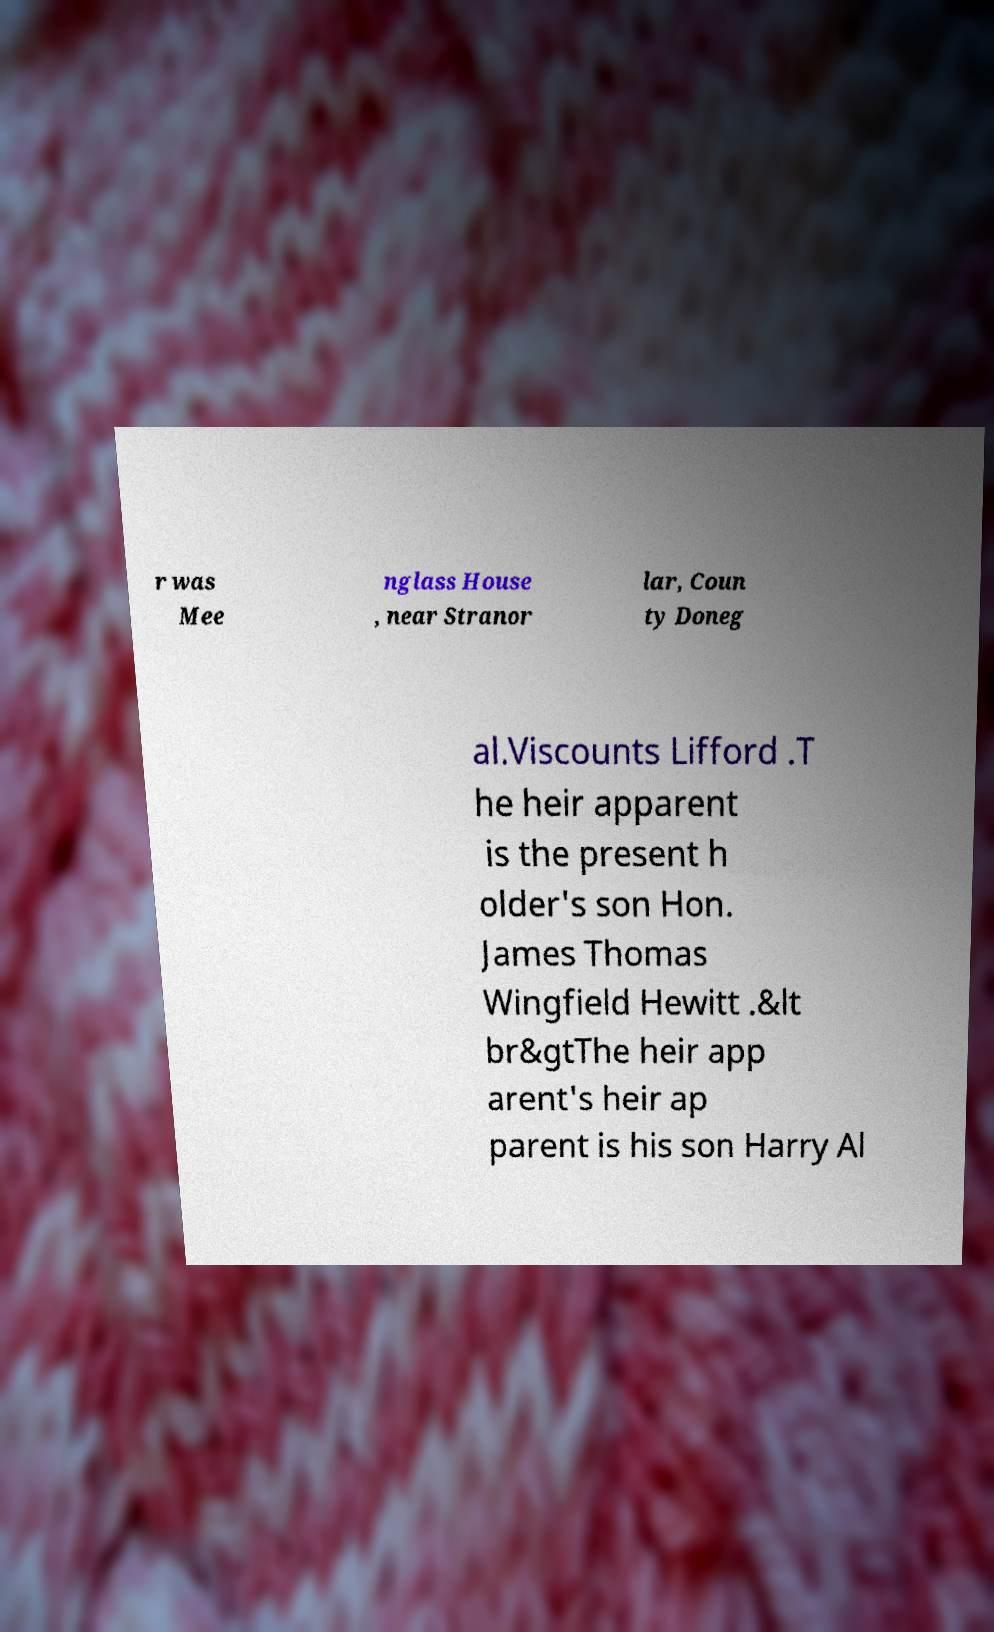Please identify and transcribe the text found in this image. r was Mee nglass House , near Stranor lar, Coun ty Doneg al.Viscounts Lifford .T he heir apparent is the present h older's son Hon. James Thomas Wingfield Hewitt .&lt br&gtThe heir app arent's heir ap parent is his son Harry Al 